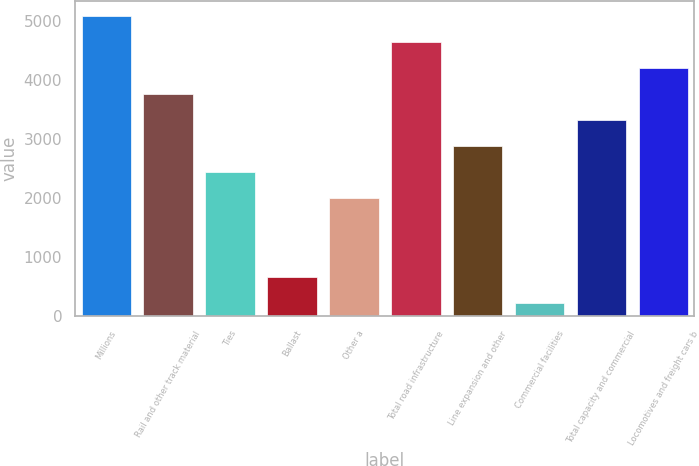Convert chart to OTSL. <chart><loc_0><loc_0><loc_500><loc_500><bar_chart><fcel>Millions<fcel>Rail and other track material<fcel>Ties<fcel>Ballast<fcel>Other a<fcel>Total road infrastructure<fcel>Line expansion and other<fcel>Commercial facilities<fcel>Total capacity and commercial<fcel>Locomotives and freight cars b<nl><fcel>5092.3<fcel>3765.4<fcel>2438.5<fcel>669.3<fcel>1996.2<fcel>4650<fcel>2880.8<fcel>227<fcel>3323.1<fcel>4207.7<nl></chart> 